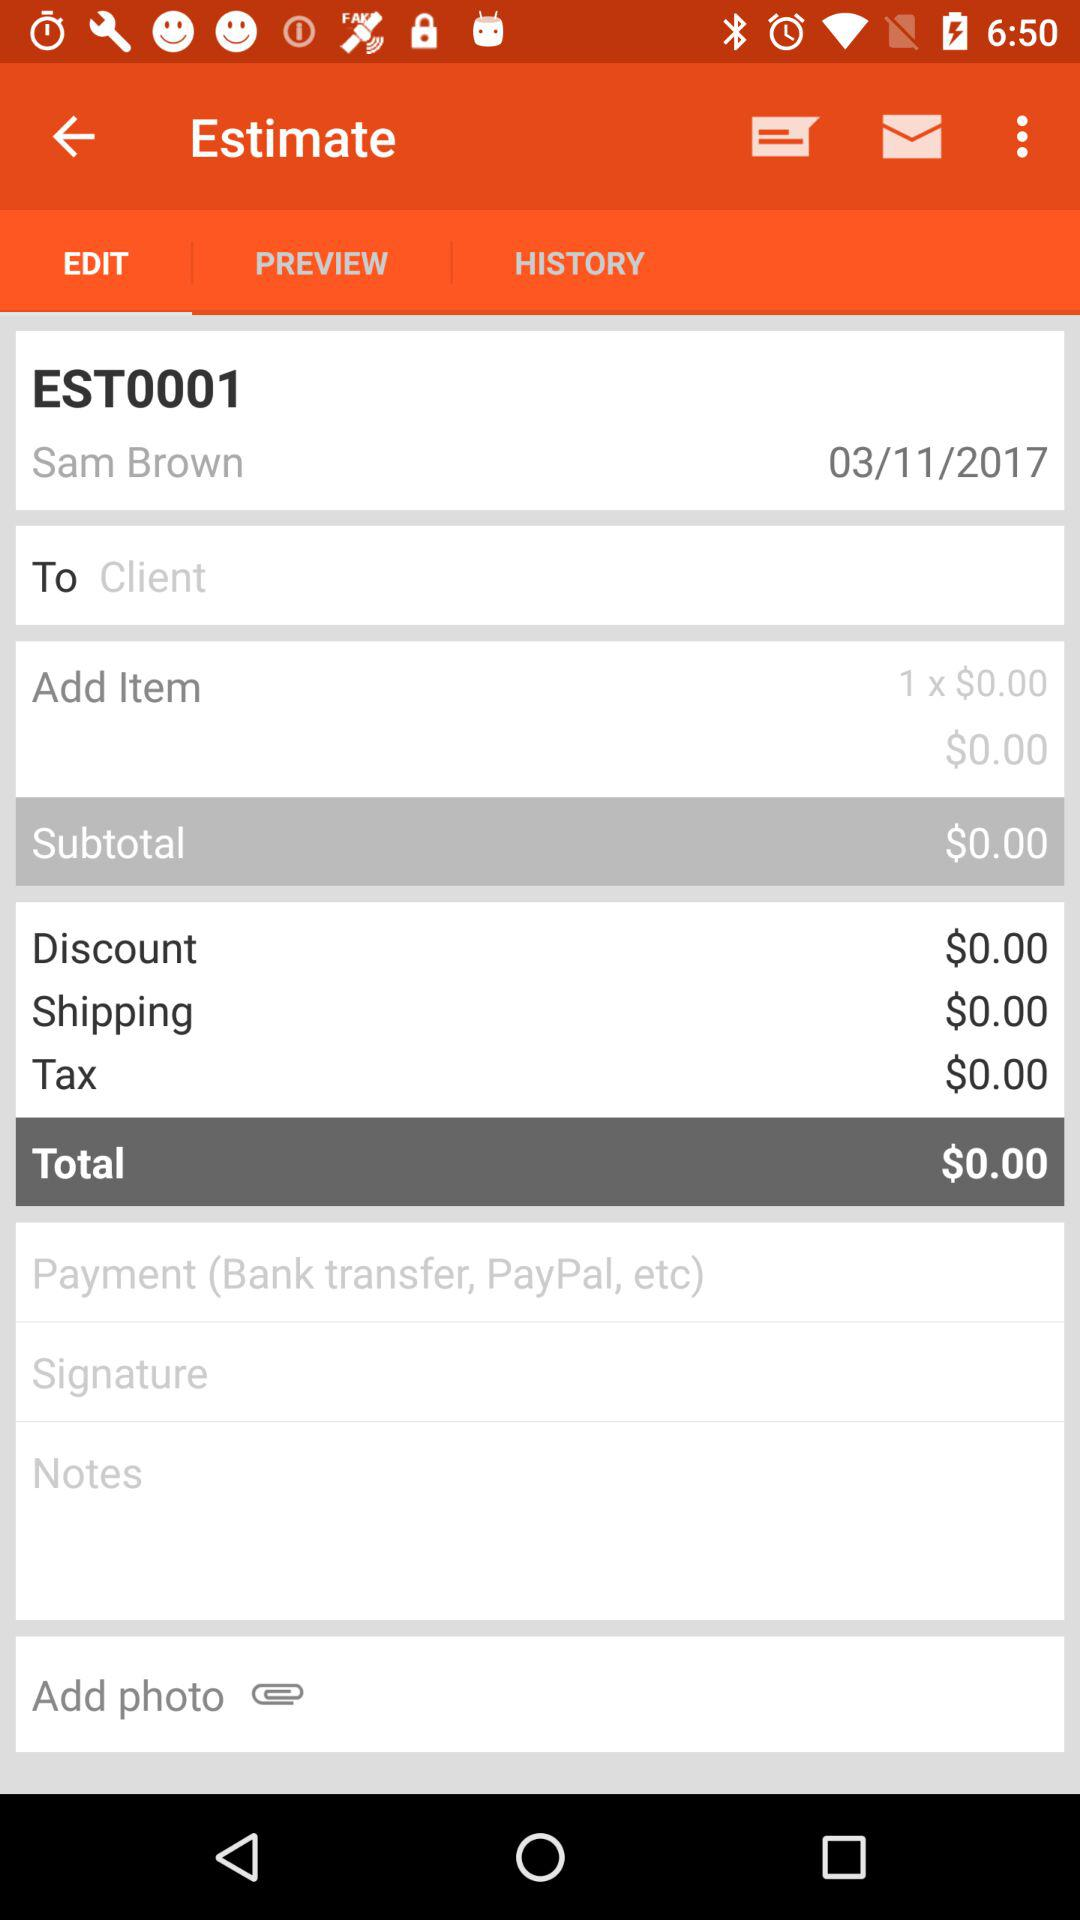What is the total price estimated? The total price estimated is $0.00. 